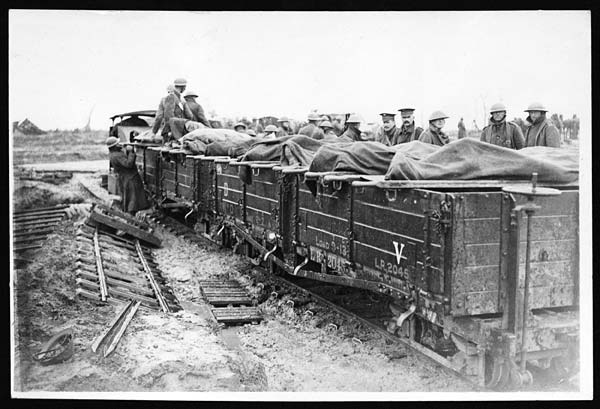Please identify all text content in this image. LR2045 